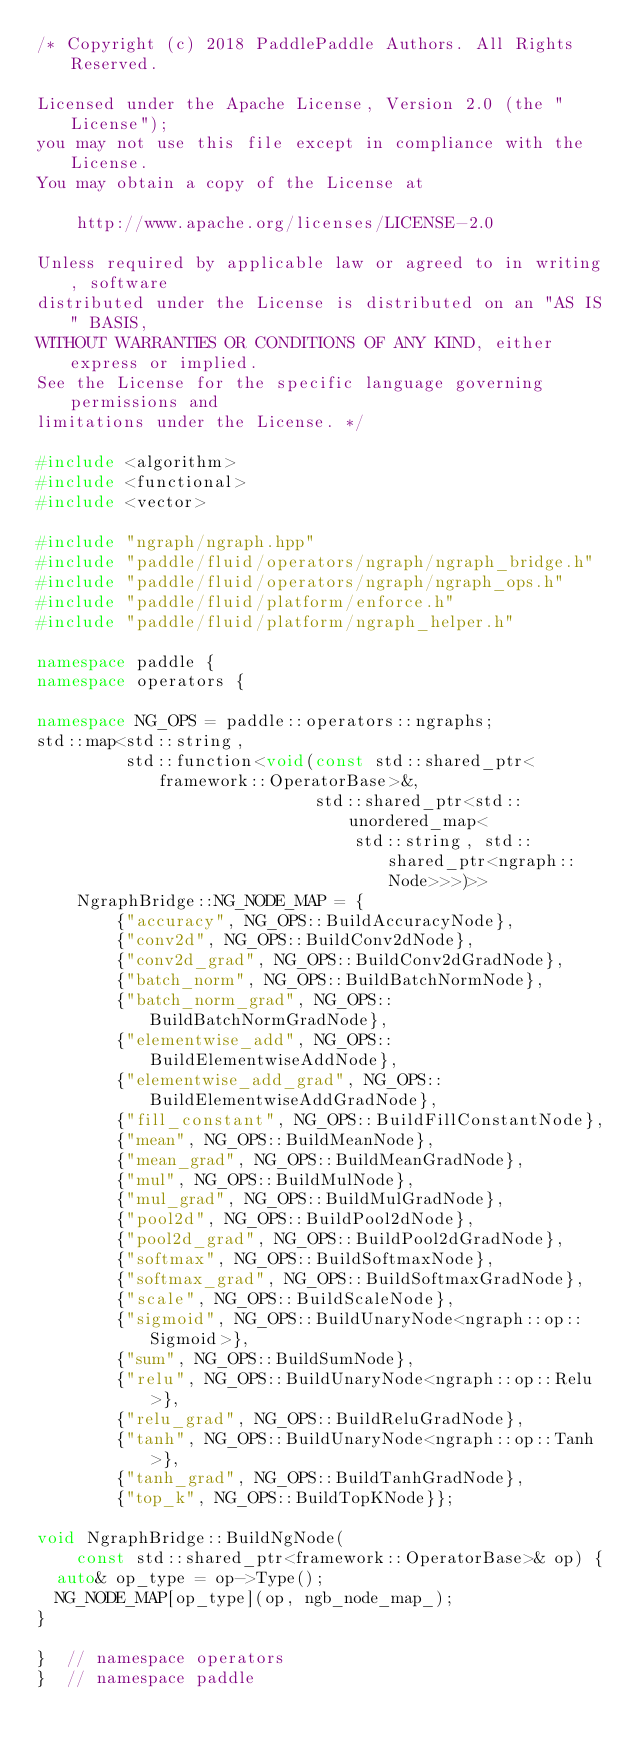<code> <loc_0><loc_0><loc_500><loc_500><_C++_>/* Copyright (c) 2018 PaddlePaddle Authors. All Rights Reserved.

Licensed under the Apache License, Version 2.0 (the "License");
you may not use this file except in compliance with the License.
You may obtain a copy of the License at

    http://www.apache.org/licenses/LICENSE-2.0

Unless required by applicable law or agreed to in writing, software
distributed under the License is distributed on an "AS IS" BASIS,
WITHOUT WARRANTIES OR CONDITIONS OF ANY KIND, either express or implied.
See the License for the specific language governing permissions and
limitations under the License. */

#include <algorithm>
#include <functional>
#include <vector>

#include "ngraph/ngraph.hpp"
#include "paddle/fluid/operators/ngraph/ngraph_bridge.h"
#include "paddle/fluid/operators/ngraph/ngraph_ops.h"
#include "paddle/fluid/platform/enforce.h"
#include "paddle/fluid/platform/ngraph_helper.h"

namespace paddle {
namespace operators {

namespace NG_OPS = paddle::operators::ngraphs;
std::map<std::string,
         std::function<void(const std::shared_ptr<framework::OperatorBase>&,
                            std::shared_ptr<std::unordered_map<
                                std::string, std::shared_ptr<ngraph::Node>>>)>>
    NgraphBridge::NG_NODE_MAP = {
        {"accuracy", NG_OPS::BuildAccuracyNode},
        {"conv2d", NG_OPS::BuildConv2dNode},
        {"conv2d_grad", NG_OPS::BuildConv2dGradNode},
        {"batch_norm", NG_OPS::BuildBatchNormNode},
        {"batch_norm_grad", NG_OPS::BuildBatchNormGradNode},
        {"elementwise_add", NG_OPS::BuildElementwiseAddNode},
        {"elementwise_add_grad", NG_OPS::BuildElementwiseAddGradNode},
        {"fill_constant", NG_OPS::BuildFillConstantNode},
        {"mean", NG_OPS::BuildMeanNode},
        {"mean_grad", NG_OPS::BuildMeanGradNode},
        {"mul", NG_OPS::BuildMulNode},
        {"mul_grad", NG_OPS::BuildMulGradNode},
        {"pool2d", NG_OPS::BuildPool2dNode},
        {"pool2d_grad", NG_OPS::BuildPool2dGradNode},
        {"softmax", NG_OPS::BuildSoftmaxNode},
        {"softmax_grad", NG_OPS::BuildSoftmaxGradNode},
        {"scale", NG_OPS::BuildScaleNode},
        {"sigmoid", NG_OPS::BuildUnaryNode<ngraph::op::Sigmoid>},
        {"sum", NG_OPS::BuildSumNode},
        {"relu", NG_OPS::BuildUnaryNode<ngraph::op::Relu>},
        {"relu_grad", NG_OPS::BuildReluGradNode},
        {"tanh", NG_OPS::BuildUnaryNode<ngraph::op::Tanh>},
        {"tanh_grad", NG_OPS::BuildTanhGradNode},
        {"top_k", NG_OPS::BuildTopKNode}};

void NgraphBridge::BuildNgNode(
    const std::shared_ptr<framework::OperatorBase>& op) {
  auto& op_type = op->Type();
  NG_NODE_MAP[op_type](op, ngb_node_map_);
}

}  // namespace operators
}  // namespace paddle
</code> 